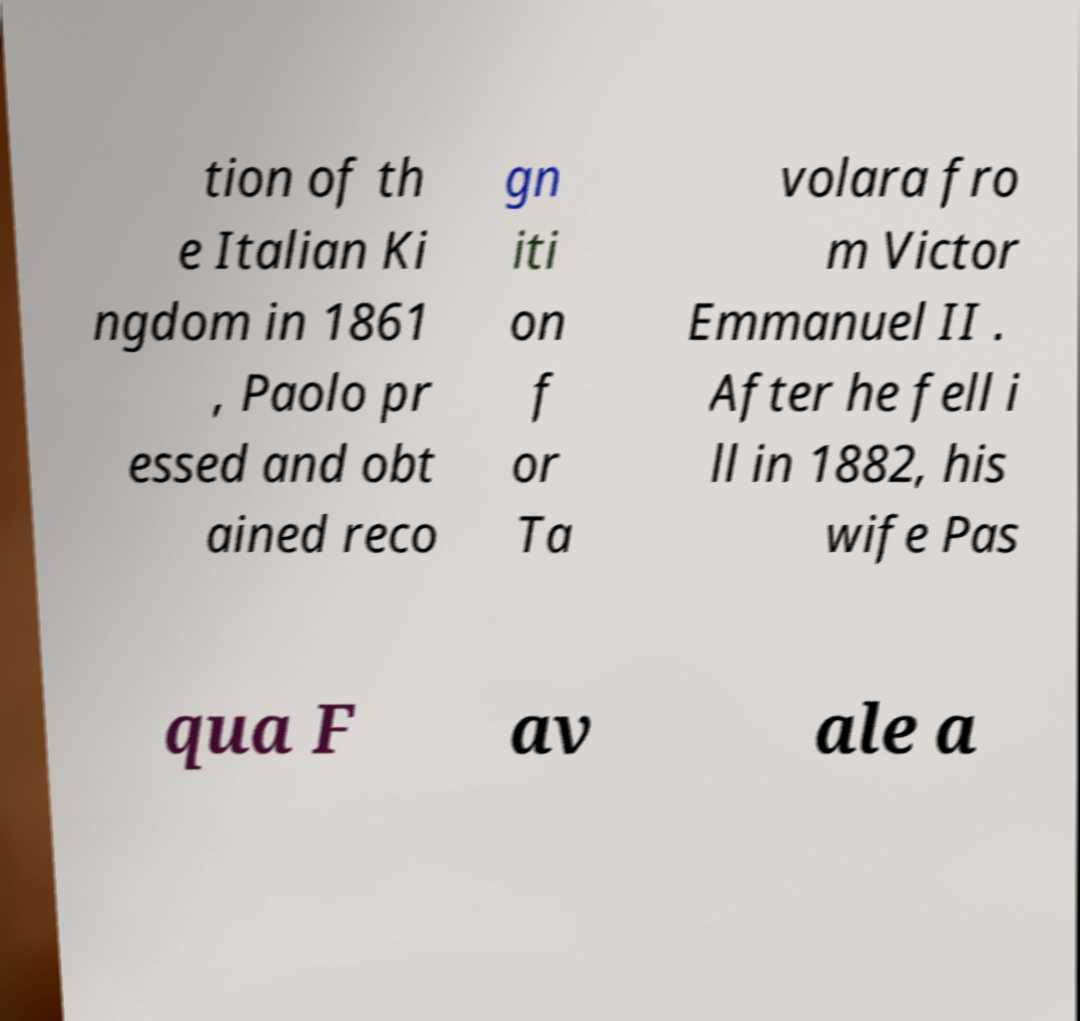There's text embedded in this image that I need extracted. Can you transcribe it verbatim? tion of th e Italian Ki ngdom in 1861 , Paolo pr essed and obt ained reco gn iti on f or Ta volara fro m Victor Emmanuel II . After he fell i ll in 1882, his wife Pas qua F av ale a 